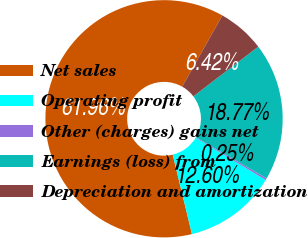Convert chart to OTSL. <chart><loc_0><loc_0><loc_500><loc_500><pie_chart><fcel>Net sales<fcel>Operating profit<fcel>Other (charges) gains net<fcel>Earnings (loss) from<fcel>Depreciation and amortization<nl><fcel>61.96%<fcel>12.6%<fcel>0.25%<fcel>18.77%<fcel>6.42%<nl></chart> 